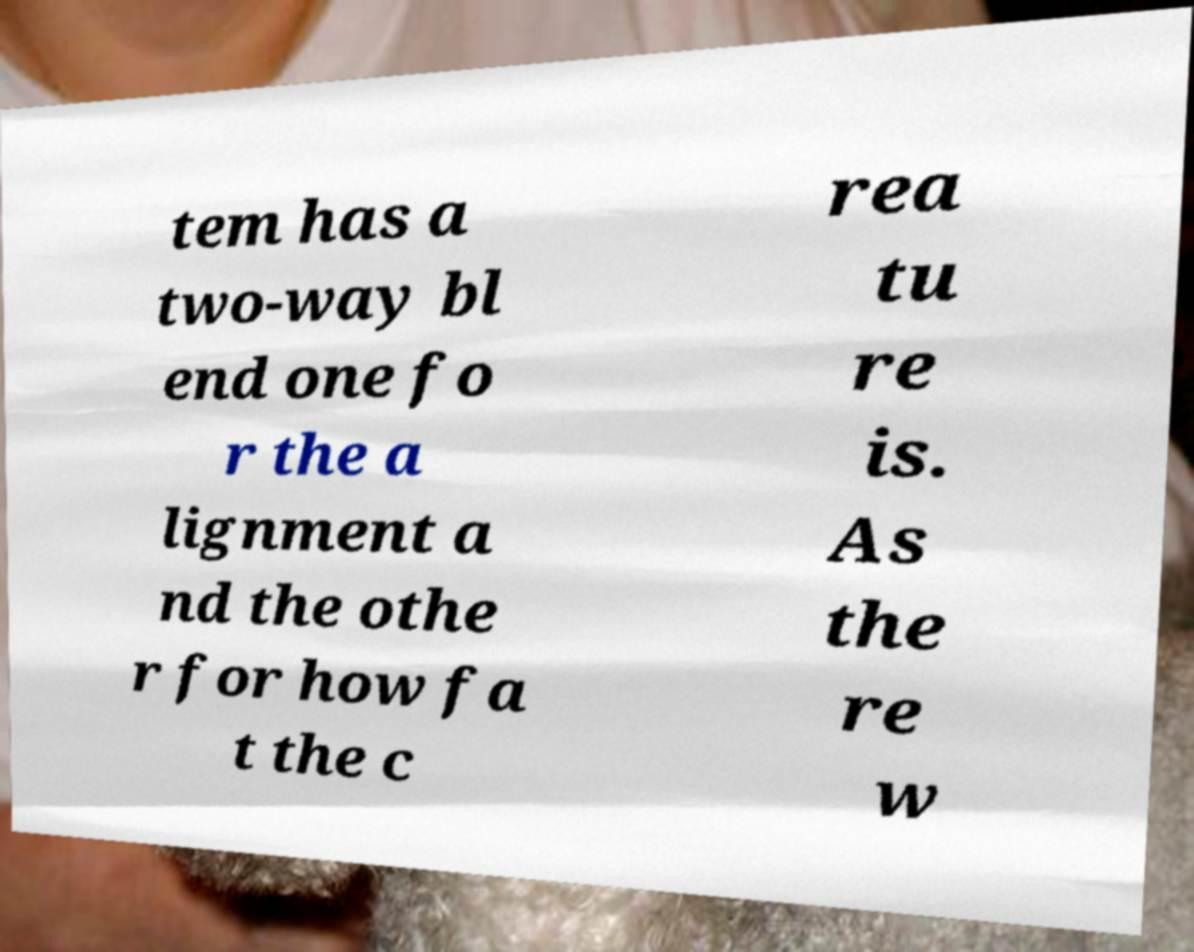I need the written content from this picture converted into text. Can you do that? tem has a two-way bl end one fo r the a lignment a nd the othe r for how fa t the c rea tu re is. As the re w 